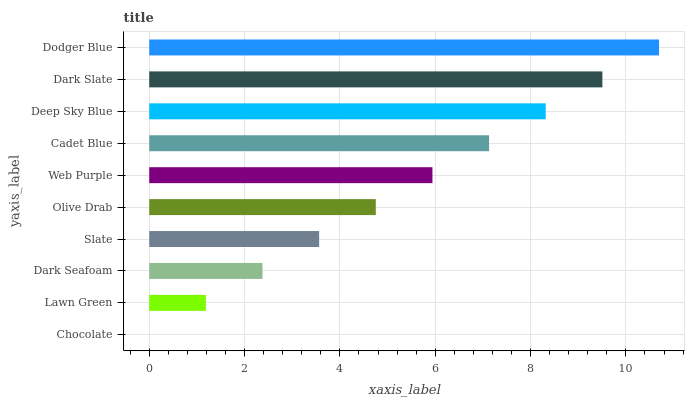Is Chocolate the minimum?
Answer yes or no. Yes. Is Dodger Blue the maximum?
Answer yes or no. Yes. Is Lawn Green the minimum?
Answer yes or no. No. Is Lawn Green the maximum?
Answer yes or no. No. Is Lawn Green greater than Chocolate?
Answer yes or no. Yes. Is Chocolate less than Lawn Green?
Answer yes or no. Yes. Is Chocolate greater than Lawn Green?
Answer yes or no. No. Is Lawn Green less than Chocolate?
Answer yes or no. No. Is Web Purple the high median?
Answer yes or no. Yes. Is Olive Drab the low median?
Answer yes or no. Yes. Is Dark Slate the high median?
Answer yes or no. No. Is Chocolate the low median?
Answer yes or no. No. 